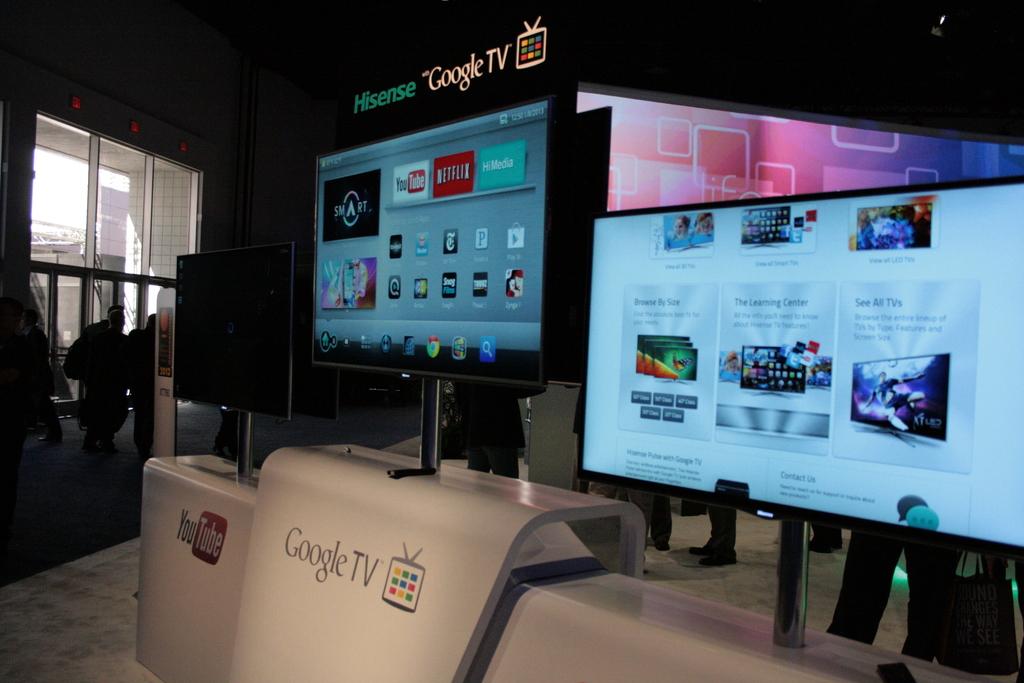What brand of computer is that?
Your answer should be compact. Google tv. What type of tv?
Give a very brief answer. Google tv. 